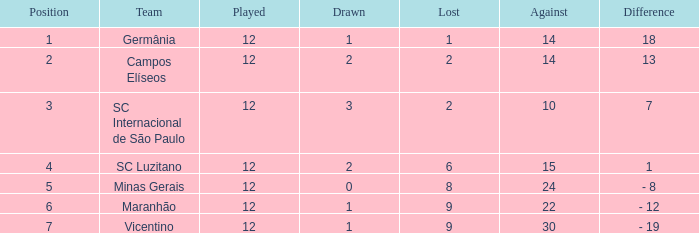What distinction has a score exceeding 10, and a tie below 2? 18.0. 